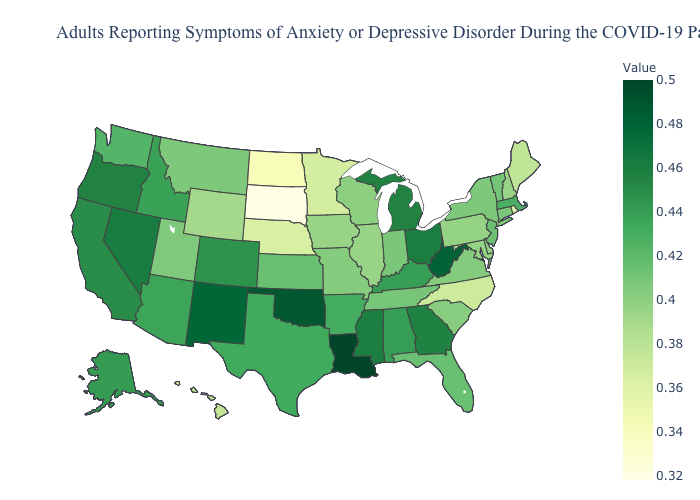Does Oklahoma have the highest value in the USA?
Write a very short answer. No. Among the states that border Massachusetts , which have the lowest value?
Give a very brief answer. Rhode Island. Among the states that border Wyoming , which have the highest value?
Give a very brief answer. Colorado. Among the states that border South Carolina , which have the highest value?
Give a very brief answer. Georgia. 